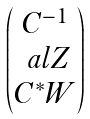<formula> <loc_0><loc_0><loc_500><loc_500>\begin{pmatrix} C ^ { - 1 } \\ \ a l Z \\ C ^ { * } W \end{pmatrix}</formula> 